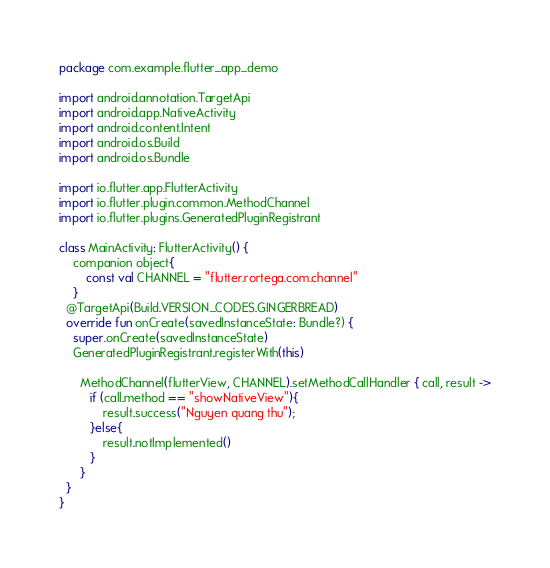Convert code to text. <code><loc_0><loc_0><loc_500><loc_500><_Kotlin_>package com.example.flutter_app_demo

import android.annotation.TargetApi
import android.app.NativeActivity
import android.content.Intent
import android.os.Build
import android.os.Bundle

import io.flutter.app.FlutterActivity
import io.flutter.plugin.common.MethodChannel
import io.flutter.plugins.GeneratedPluginRegistrant

class MainActivity: FlutterActivity() {
    companion object{
        const val CHANNEL = "flutter.rortega.com.channel"
    }
  @TargetApi(Build.VERSION_CODES.GINGERBREAD)
  override fun onCreate(savedInstanceState: Bundle?) {
    super.onCreate(savedInstanceState)
    GeneratedPluginRegistrant.registerWith(this)

      MethodChannel(flutterView, CHANNEL).setMethodCallHandler { call, result ->
         if (call.method == "showNativeView"){
             result.success("Nguyen quang thu");
         }else{
             result.notImplemented()
         }
      }
  }
}
</code> 